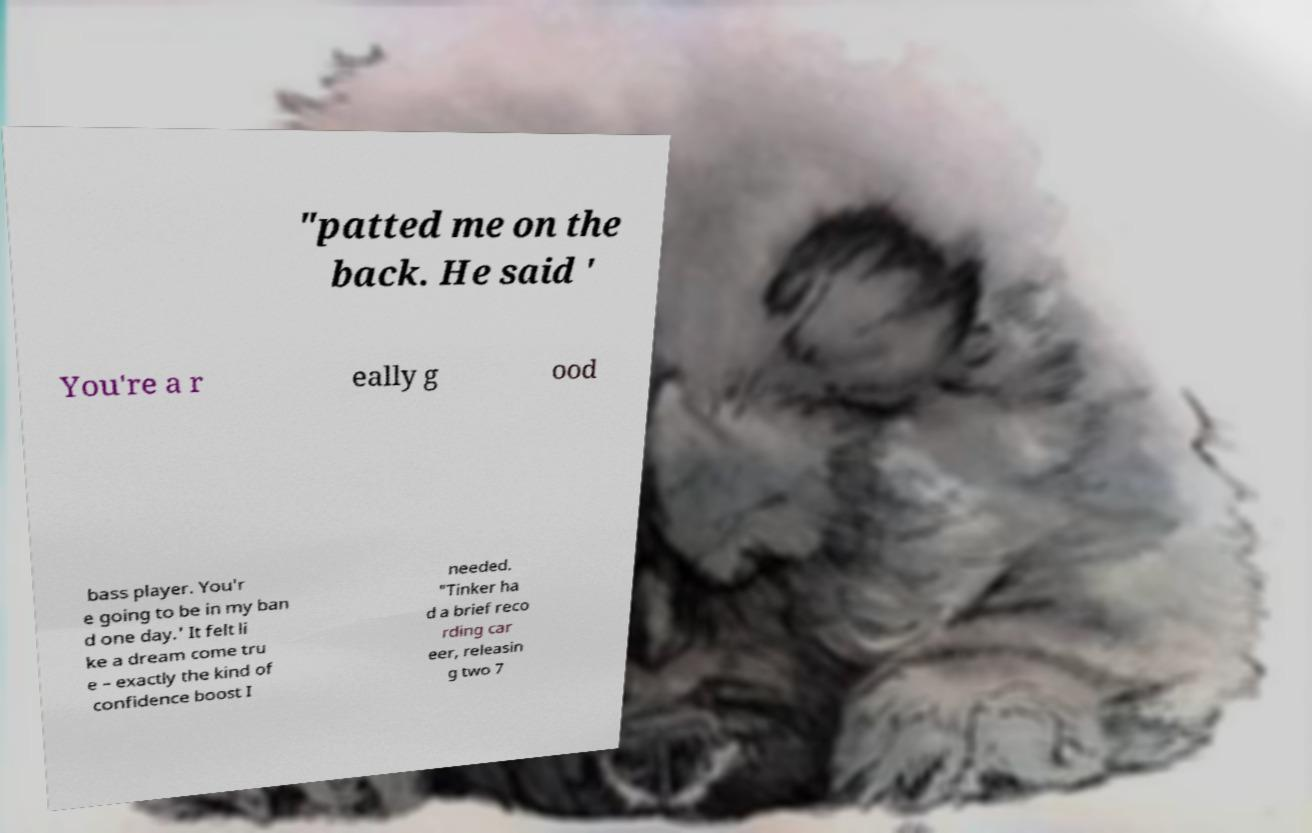For documentation purposes, I need the text within this image transcribed. Could you provide that? "patted me on the back. He said ' You're a r eally g ood bass player. You'r e going to be in my ban d one day.' It felt li ke a dream come tru e – exactly the kind of confidence boost I needed. "Tinker ha d a brief reco rding car eer, releasin g two 7 